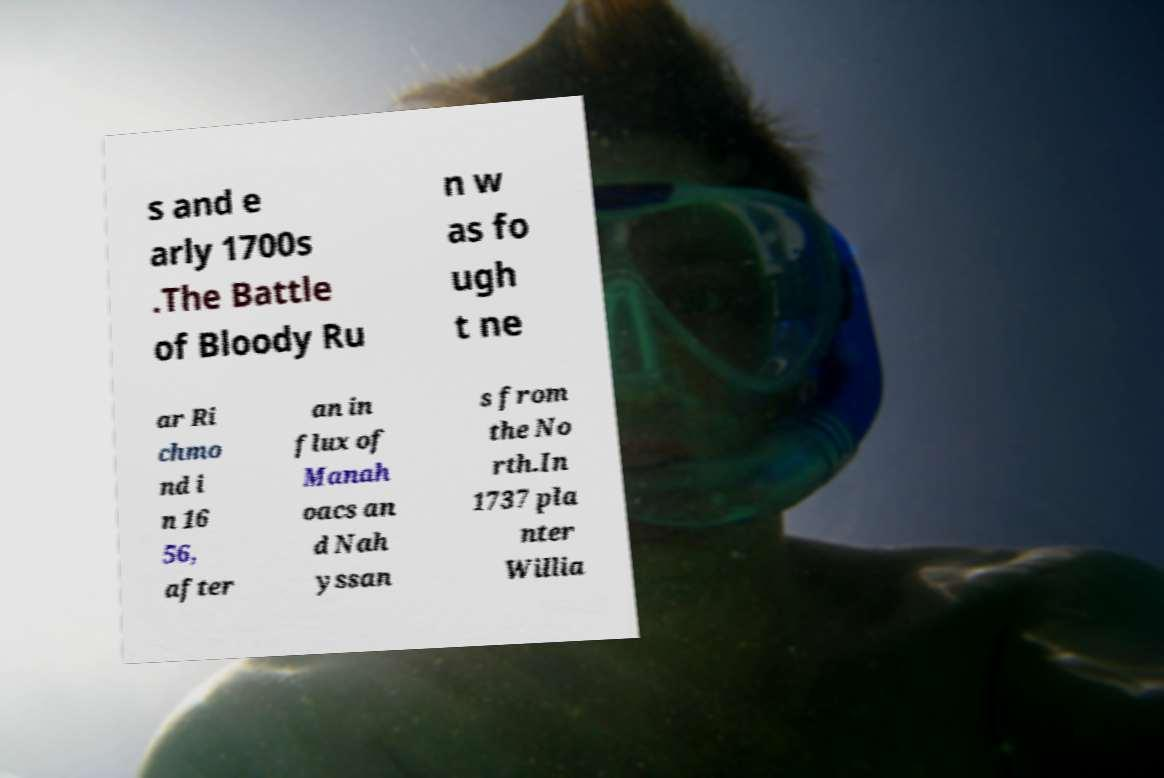Could you assist in decoding the text presented in this image and type it out clearly? s and e arly 1700s .The Battle of Bloody Ru n w as fo ugh t ne ar Ri chmo nd i n 16 56, after an in flux of Manah oacs an d Nah yssan s from the No rth.In 1737 pla nter Willia 